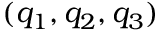<formula> <loc_0><loc_0><loc_500><loc_500>( q _ { 1 } , q _ { 2 } , q _ { 3 } )</formula> 